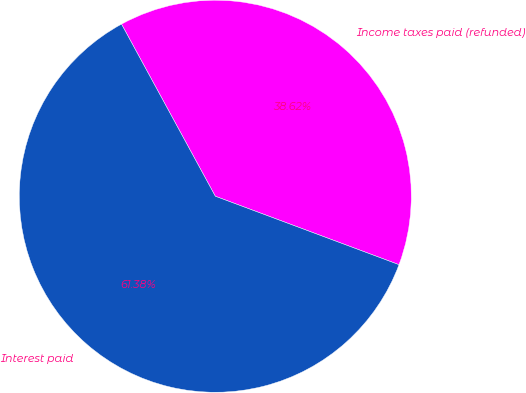<chart> <loc_0><loc_0><loc_500><loc_500><pie_chart><fcel>Income taxes paid (refunded)<fcel>Interest paid<nl><fcel>38.62%<fcel>61.38%<nl></chart> 